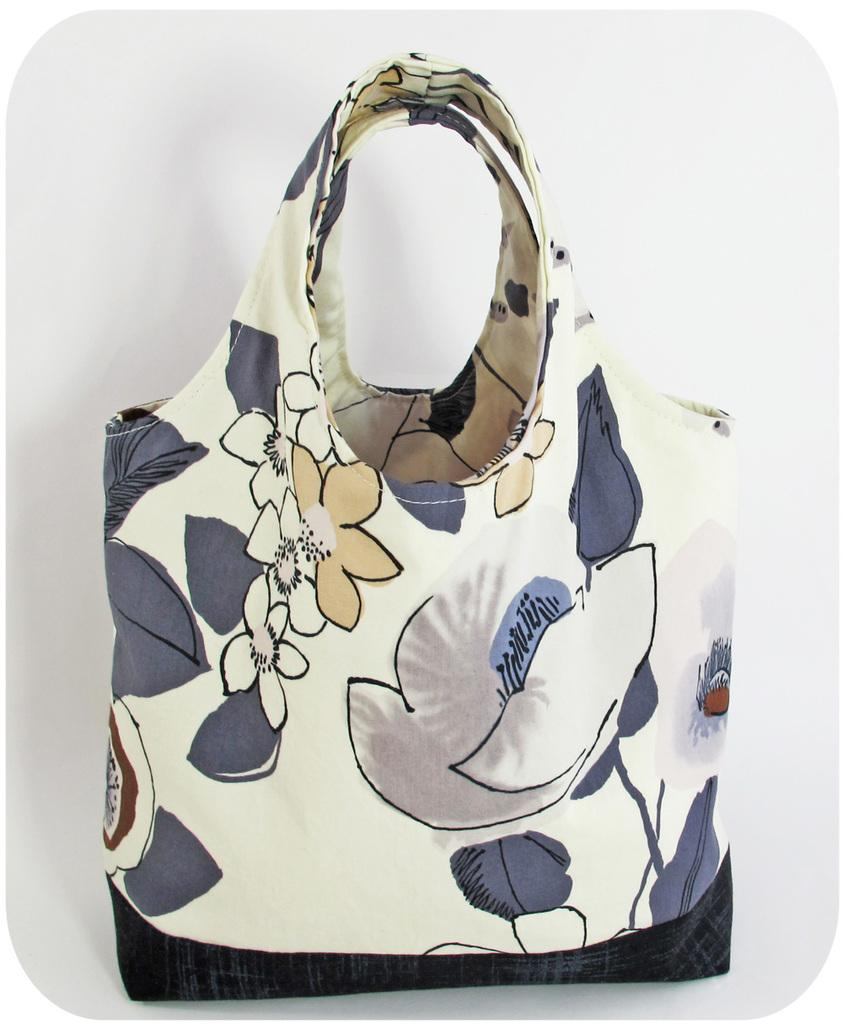What object can be seen in the image? There is a bag in the image. Can you tell me how many rivers are visible in the image? There are no rivers visible in the image; it only features a bag. What type of meal is being prepared in the image? There is no meal preparation visible in the image; it only features a bag. 